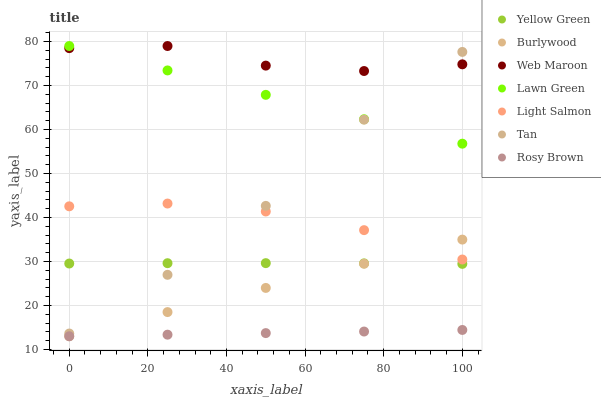Does Rosy Brown have the minimum area under the curve?
Answer yes or no. Yes. Does Web Maroon have the maximum area under the curve?
Answer yes or no. Yes. Does Light Salmon have the minimum area under the curve?
Answer yes or no. No. Does Light Salmon have the maximum area under the curve?
Answer yes or no. No. Is Burlywood the smoothest?
Answer yes or no. Yes. Is Web Maroon the roughest?
Answer yes or no. Yes. Is Light Salmon the smoothest?
Answer yes or no. No. Is Light Salmon the roughest?
Answer yes or no. No. Does Burlywood have the lowest value?
Answer yes or no. Yes. Does Light Salmon have the lowest value?
Answer yes or no. No. Does Web Maroon have the highest value?
Answer yes or no. Yes. Does Light Salmon have the highest value?
Answer yes or no. No. Is Burlywood less than Lawn Green?
Answer yes or no. Yes. Is Lawn Green greater than Light Salmon?
Answer yes or no. Yes. Does Lawn Green intersect Tan?
Answer yes or no. Yes. Is Lawn Green less than Tan?
Answer yes or no. No. Is Lawn Green greater than Tan?
Answer yes or no. No. Does Burlywood intersect Lawn Green?
Answer yes or no. No. 